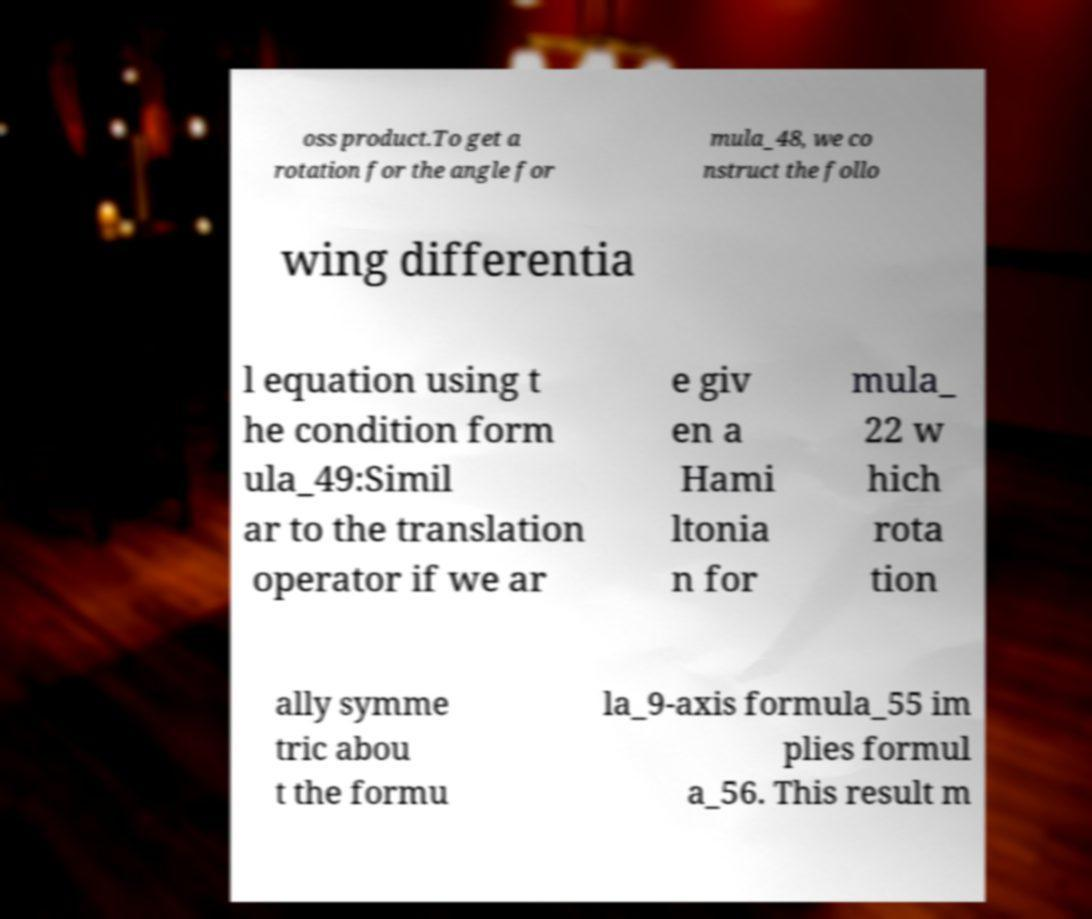For documentation purposes, I need the text within this image transcribed. Could you provide that? oss product.To get a rotation for the angle for mula_48, we co nstruct the follo wing differentia l equation using t he condition form ula_49:Simil ar to the translation operator if we ar e giv en a Hami ltonia n for mula_ 22 w hich rota tion ally symme tric abou t the formu la_9-axis formula_55 im plies formul a_56. This result m 